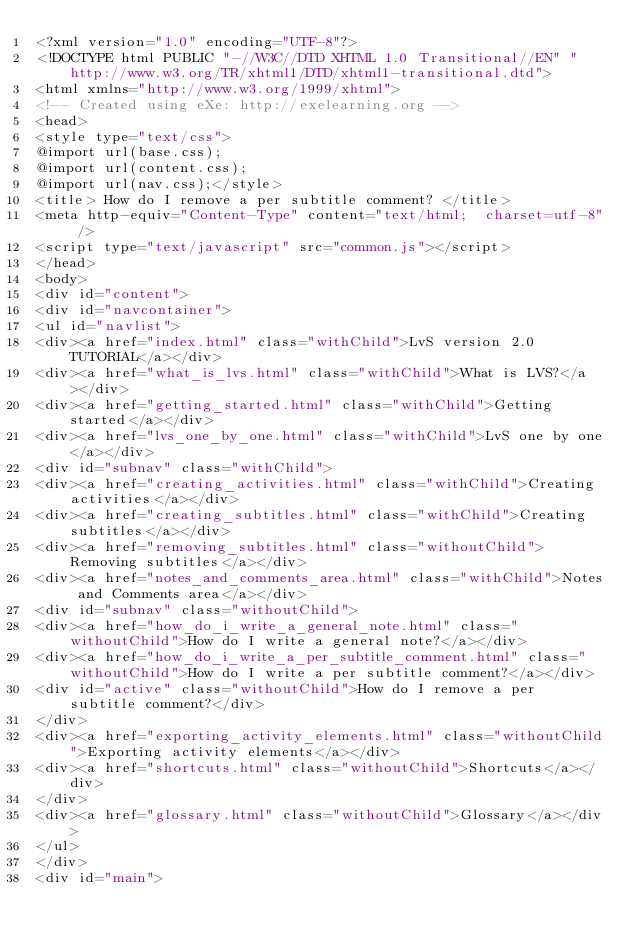<code> <loc_0><loc_0><loc_500><loc_500><_HTML_><?xml version="1.0" encoding="UTF-8"?>
<!DOCTYPE html PUBLIC "-//W3C//DTD XHTML 1.0 Transitional//EN" "http://www.w3.org/TR/xhtml1/DTD/xhtml1-transitional.dtd">
<html xmlns="http://www.w3.org/1999/xhtml">
<!-- Created using eXe: http://exelearning.org -->
<head>
<style type="text/css">
@import url(base.css);
@import url(content.css);
@import url(nav.css);</style>
<title> How do I remove a per subtitle comment? </title>
<meta http-equiv="Content-Type" content="text/html;  charset=utf-8" />
<script type="text/javascript" src="common.js"></script>
</head>
<body>
<div id="content">
<div id="navcontainer">
<ul id="navlist">
<div><a href="index.html" class="withChild">LvS version 2.0 TUTORIAL</a></div>
<div><a href="what_is_lvs.html" class="withChild">What is LVS?</a></div>
<div><a href="getting_started.html" class="withChild">Getting started</a></div>
<div><a href="lvs_one_by_one.html" class="withChild">LvS one by one</a></div>
<div id="subnav" class="withChild">
<div><a href="creating_activities.html" class="withChild">Creating activities</a></div>
<div><a href="creating_subtitles.html" class="withChild">Creating subtitles</a></div>
<div><a href="removing_subtitles.html" class="withoutChild">Removing subtitles</a></div>
<div><a href="notes_and_comments_area.html" class="withChild">Notes and Comments area</a></div>
<div id="subnav" class="withoutChild">
<div><a href="how_do_i_write_a_general_note.html" class="withoutChild">How do I write a general note?</a></div>
<div><a href="how_do_i_write_a_per_subtitle_comment.html" class="withoutChild">How do I write a per subtitle comment?</a></div>
<div id="active" class="withoutChild">How do I remove a per subtitle comment?</div>
</div>
<div><a href="exporting_activity_elements.html" class="withoutChild">Exporting activity elements</a></div>
<div><a href="shortcuts.html" class="withoutChild">Shortcuts</a></div>
</div>
<div><a href="glossary.html" class="withoutChild">Glossary</a></div>
</ul>
</div>
<div id="main"></code> 